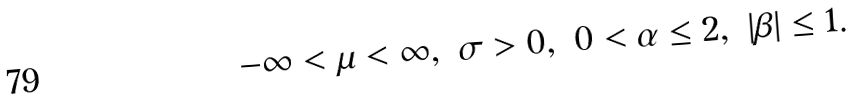Convert formula to latex. <formula><loc_0><loc_0><loc_500><loc_500>- \infty < \mu < \infty , \ \sigma > 0 , \ 0 < \alpha \leq 2 , \ | \beta | \leq 1 .</formula> 